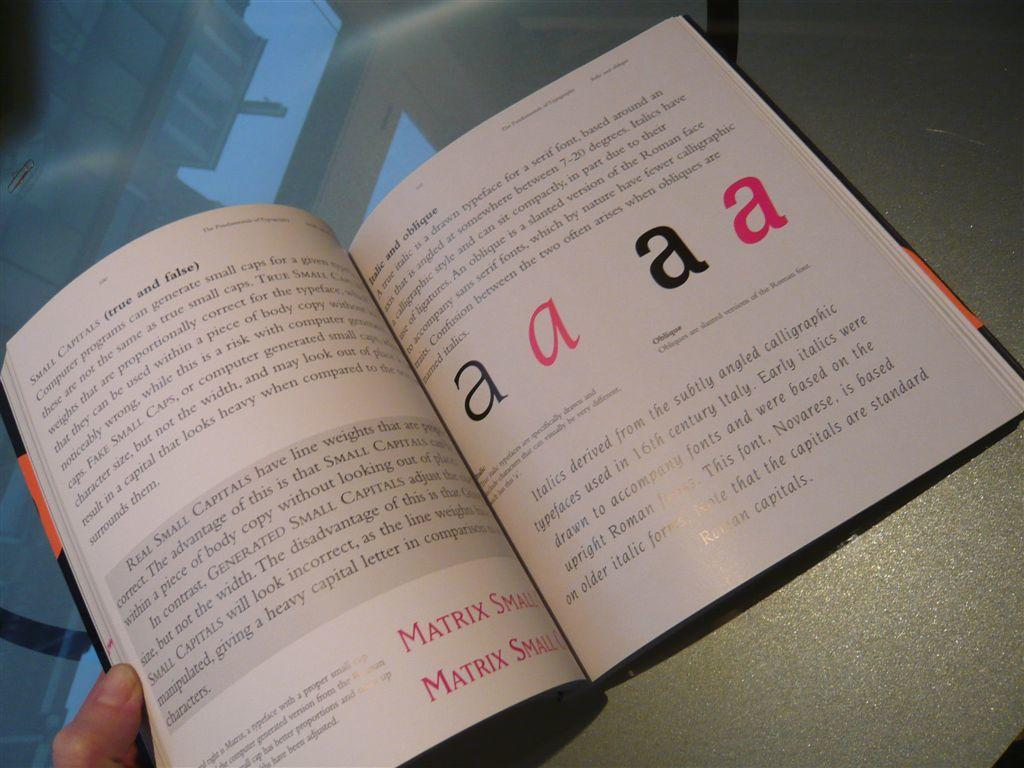<image>
Give a short and clear explanation of the subsequent image. A person holding an open text book with large letter A's in it. 